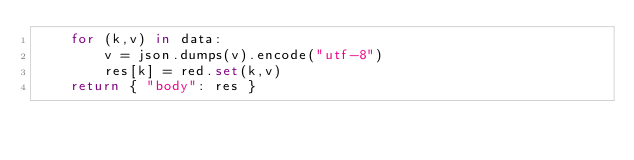Convert code to text. <code><loc_0><loc_0><loc_500><loc_500><_Python_>    for (k,v) in data:
        v = json.dumps(v).encode("utf-8")
        res[k] = red.set(k,v)
    return { "body": res }
</code> 